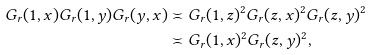Convert formula to latex. <formula><loc_0><loc_0><loc_500><loc_500>G _ { r } ( 1 , x ) G _ { r } ( 1 , y ) G _ { r } ( y , x ) & \asymp G _ { r } ( 1 , z ) ^ { 2 } G _ { r } ( z , x ) ^ { 2 } G _ { r } ( z , y ) ^ { 2 } \\ & \asymp G _ { r } ( 1 , x ) ^ { 2 } G _ { r } ( z , y ) ^ { 2 } ,</formula> 